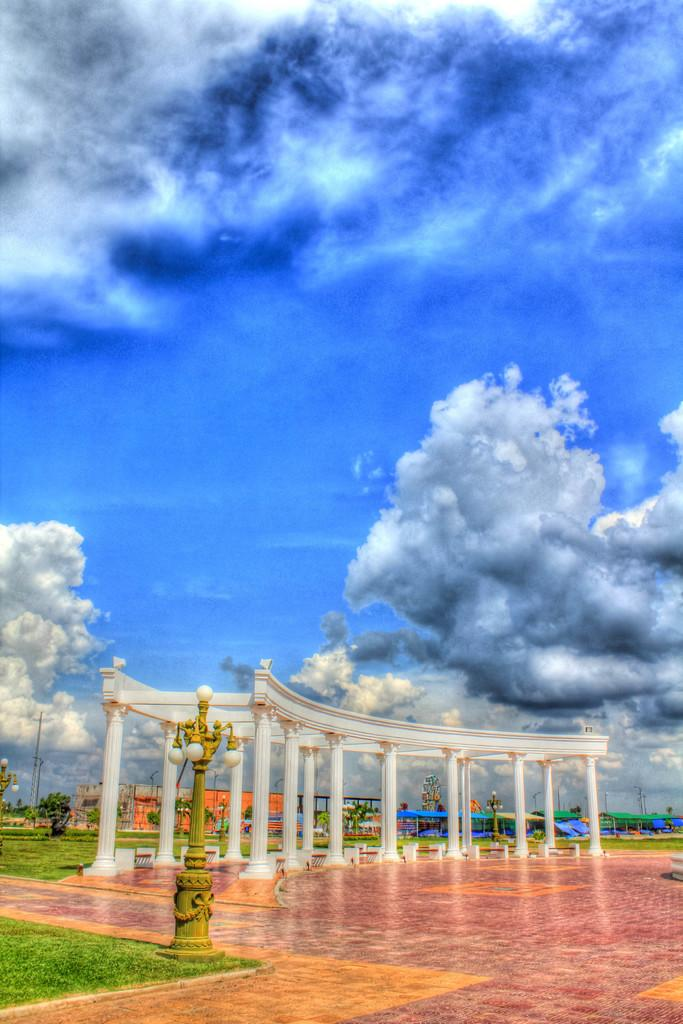What architectural features can be seen in the image? There are pillars and poles in the image. What type of lighting is present in the image? There are lights in the image. What type of vegetation is present in the image? There are plants in the image. What is the ground covered with in the image? The ground is covered with grass. What is visible in the background of the image? The sky is visible in the background of the image. What is the condition of the sky in the image? The sky has heavy clouds in the image. What facial expression can be seen on the moon in the image? There is no moon present in the image, and therefore no facial expression can be observed. What direction is the north pole pointing in the image? There is no reference to a north pole or any directional indicators in the image. 